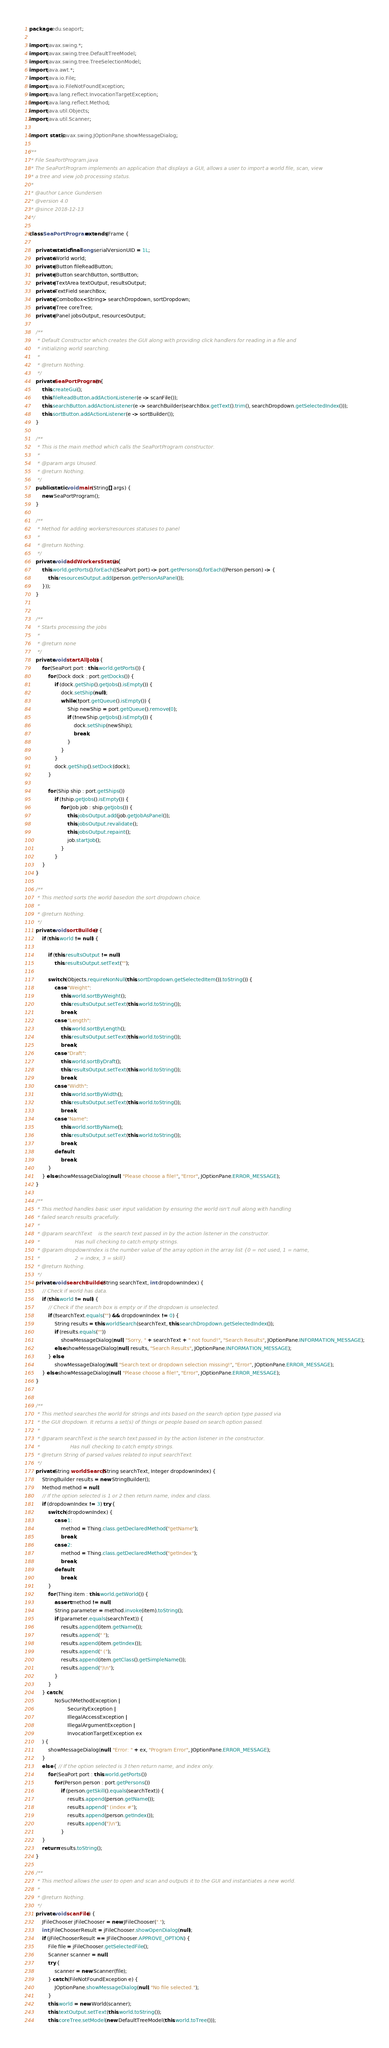<code> <loc_0><loc_0><loc_500><loc_500><_Java_>package edu.seaport;

import javax.swing.*;
import javax.swing.tree.DefaultTreeModel;
import javax.swing.tree.TreeSelectionModel;
import java.awt.*;
import java.io.File;
import java.io.FileNotFoundException;
import java.lang.reflect.InvocationTargetException;
import java.lang.reflect.Method;
import java.util.Objects;
import java.util.Scanner;

import static javax.swing.JOptionPane.showMessageDialog;

/**
 * File SeaPortProgram.java
 * The SeaPortProgram implements an application that displays a GUI, allows a user to import a world file, scan, view
 * a tree and view job processing status.
 *
 * @author Lance Gundersen
 * @version 4.0
 * @since 2018-12-13
 */

class SeaPortProgram extends JFrame {

    private static final long serialVersionUID = 1L;
    private World world;
    private JButton fileReadButton;
    private JButton searchButton, sortButton;
    private JTextArea textOutput, resultsOutput;
    private TextField searchBox;
    private JComboBox<String> searchDropdown, sortDropdown;
    private JTree coreTree;
    private JPanel jobsOutput, resourcesOutput;

    /**
     * Default Constructor which creates the GUI along with providing click handlers for reading in a file and
     * initializing world searching.
     *
     * @return Nothing.
     */
    private SeaPortProgram() {
        this.createGui();
        this.fileReadButton.addActionListener(e -> scanFile());
        this.searchButton.addActionListener(e -> searchBuilder(searchBox.getText().trim(), searchDropdown.getSelectedIndex()));
        this.sortButton.addActionListener(e -> sortBuilder());
    }

    /**
     * This is the main method which calls the SeaPortProgram constructor.
     *
     * @param args Unused.
     * @return Nothing.
     */
    public static void main(String[] args) {
        new SeaPortProgram();
    }

    /**
     * Method for adding workers/resources statuses to panel
     *
     * @return Nothing.
     */
    private void addWorkersStatus() {
        this.world.getPorts().forEach((SeaPort port) -> port.getPersons().forEach((Person person) -> {
            this.resourcesOutput.add(person.getPersonAsPanel());
        }));
    }


    /**
     * Starts processing the jobs
     *
     * @return none
     */
    private void startAllJobs() {
        for (SeaPort port : this.world.getPorts()) {
            for (Dock dock : port.getDocks()) {
                if (dock.getShip().getJobs().isEmpty()) {
                    dock.setShip(null);
                    while (!port.getQueue().isEmpty()) {
                        Ship newShip = port.getQueue().remove(0);
                        if (!newShip.getJobs().isEmpty()) {
                            dock.setShip(newShip);
                            break;
                        }
                    }
                }
                dock.getShip().setDock(dock);
            }

            for (Ship ship : port.getShips())
                if (!ship.getJobs().isEmpty()) {
                    for (Job job : ship.getJobs()) {
                        this.jobsOutput.add(job.getJobAsPanel());
                        this.jobsOutput.revalidate();
                        this.jobsOutput.repaint();
                        job.startJob();
                    }
                }
        }
    }

    /**
     * This method sorts the world basedon the sort dropdown choice.
     *
     * @return Nothing.
     */
    private void sortBuilder() {
        if (this.world != null) {

            if (this.resultsOutput != null)
                this.resultsOutput.setText("");

            switch (Objects.requireNonNull(this.sortDropdown.getSelectedItem()).toString()) {
                case "Weight":
                    this.world.sortByWeight();
                    this.resultsOutput.setText(this.world.toString());
                    break;
                case "Length":
                    this.world.sortByLength();
                    this.resultsOutput.setText(this.world.toString());
                    break;
                case "Draft":
                    this.world.sortByDraft();
                    this.resultsOutput.setText(this.world.toString());
                    break;
                case "Width":
                    this.world.sortByWidth();
                    this.resultsOutput.setText(this.world.toString());
                    break;
                case "Name":
                    this.world.sortByName();
                    this.resultsOutput.setText(this.world.toString());
                    break;
                default:
                    break;
            }
        } else showMessageDialog(null, "Please choose a file!", "Error", JOptionPane.ERROR_MESSAGE);
    }

    /**
     * This method handles basic user input validation by ensuring the world isn't null along with handling
     * failed search results gracefully.
     *
     * @param searchText    is the search text passed in by the action listener in the constructor.
     *                      Has null checking to catch empty strings.
     * @param dropdownIndex is the number value of the array option in the array list {0 = not used, 1 = name,
     *                      2 = index, 3 = skill}
     * @return Nothing.
     */
    private void searchBuilder(String searchText, int dropdownIndex) {
        // Check if world has data.
        if (this.world != null) {
            // Check if the search box is empty or if the dropdown is unselected.
            if (!searchText.equals("") && dropdownIndex != 0) {
                String results = this.worldSearch(searchText, this.searchDropdown.getSelectedIndex());
                if (results.equals(""))
                    showMessageDialog(null, "Sorry, " + searchText + " not found!", "Search Results", JOptionPane.INFORMATION_MESSAGE);
                else showMessageDialog(null, results, "Search Results", JOptionPane.INFORMATION_MESSAGE);
            } else
                showMessageDialog(null, "Search text or dropdown selection missing!", "Error", JOptionPane.ERROR_MESSAGE);
        } else showMessageDialog(null, "Please choose a file!", "Error", JOptionPane.ERROR_MESSAGE);
    }


    /**
     * This method searches the world for strings and ints based on the search option type passed via
     * the GUI dropdown. It returns a set(s) of things or people based on search option passed.
     *
     * @param searchText is the search text passed in by the action listener in the constructor.
     *                   Has null checking to catch empty strings.
     * @return String of parsed values related to input searchText.
     */
    private String worldSearch(String searchText, Integer dropdownIndex) {
        StringBuilder results = new StringBuilder();
        Method method = null;
        // If the option selected is 1 or 2 then return name, index and class.
        if (dropdownIndex != 3) try {
            switch (dropdownIndex) {
                case 1:
                    method = Thing.class.getDeclaredMethod("getName");
                    break;
                case 2:
                    method = Thing.class.getDeclaredMethod("getIndex");
                    break;
                default:
                    break;
            }
            for (Thing item : this.world.getWorld()) {
                assert method != null;
                String parameter = method.invoke(item).toString();
                if (parameter.equals(searchText)) {
                    results.append(item.getName());
                    results.append(" ");
                    results.append(item.getIndex());
                    results.append(" (");
                    results.append(item.getClass().getSimpleName());
                    results.append(")\n");
                }
            }
        } catch (
                NoSuchMethodException |
                        SecurityException |
                        IllegalAccessException |
                        IllegalArgumentException |
                        InvocationTargetException ex
        ) {
            showMessageDialog(null, "Error: " + ex, "Program Error", JOptionPane.ERROR_MESSAGE);
        }
        else { // If the option selected is 3 then return name, and index only.
            for (SeaPort port : this.world.getPorts())
                for (Person person : port.getPersons())
                    if (person.getSkill().equals(searchText)) {
                        results.append(person.getName());
                        results.append(" (index #");
                        results.append(person.getIndex());
                        results.append(")\n");
                    }
        }
        return results.toString();
    }

    /**
     * This method allows the user to open and scan and outputs it to the GUI and instantiates a new world.
     *
     * @return Nothing.
     */
    private void scanFile() {
        JFileChooser jFileChooser = new JFileChooser(".");
        int jFileChooserResult = jFileChooser.showOpenDialog(null);
        if (jFileChooserResult == JFileChooser.APPROVE_OPTION) {
            File file = jFileChooser.getSelectedFile();
            Scanner scanner = null;
            try {
                scanner = new Scanner(file);
            } catch (FileNotFoundException e) {
                JOptionPane.showMessageDialog(null, "No file selected.");
            }
            this.world = new World(scanner);
            this.textOutput.setText(this.world.toString());
            this.coreTree.setModel(new DefaultTreeModel(this.world.toTree()));</code> 